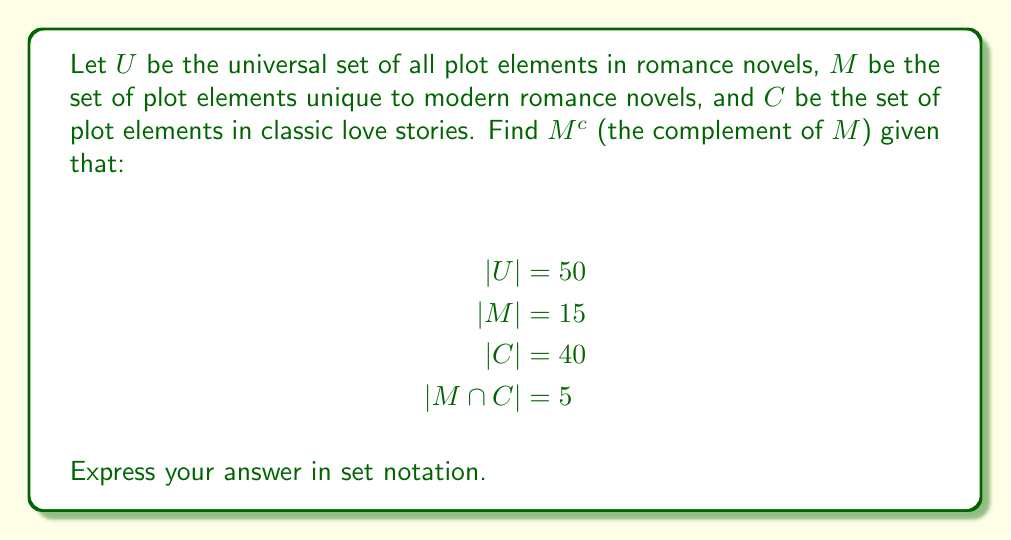Can you solve this math problem? To solve this problem, let's follow these steps:

1) First, we need to understand what $M^c$ represents. It's the set of all elements in $U$ that are not in $M$.

2) We can represent this as: $M^c = U \setminus M$

3) To find the number of elements in $M^c$, we can use the formula:
   $|M^c| = |U| - |M|$

4) We're given that $|U| = 50$ and $|M| = 15$, so:
   $|M^c| = 50 - 15 = 35$

5) Now, we need to describe these 35 elements. We know that:
   - Some of these elements are in $C$ (classic love stories)
   - Some might be in neither $M$ nor $C$

6) To find how many elements are in $C$ but not in $M$, we can use:
   $|C \setminus M| = |C| - |M \cap C| = 40 - 5 = 35$

7) This means all 35 elements of $M^c$ are in $C$.

8) Therefore, we can express $M^c$ as the union of two sets:
   - Elements in $C$ but not in $M$: $C \setminus M$
   - Elements in neither $C$ nor $M$: $U \setminus (C \cup M)$

9) But since we found that all elements of $M^c$ are in $C$, the second set is empty.

Thus, $M^c = C \setminus M$
Answer: $M^c = C \setminus M$ 